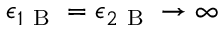Convert formula to latex. <formula><loc_0><loc_0><loc_500><loc_500>\epsilon _ { 1 B } = \epsilon _ { 2 B } \rightarrow \infty</formula> 